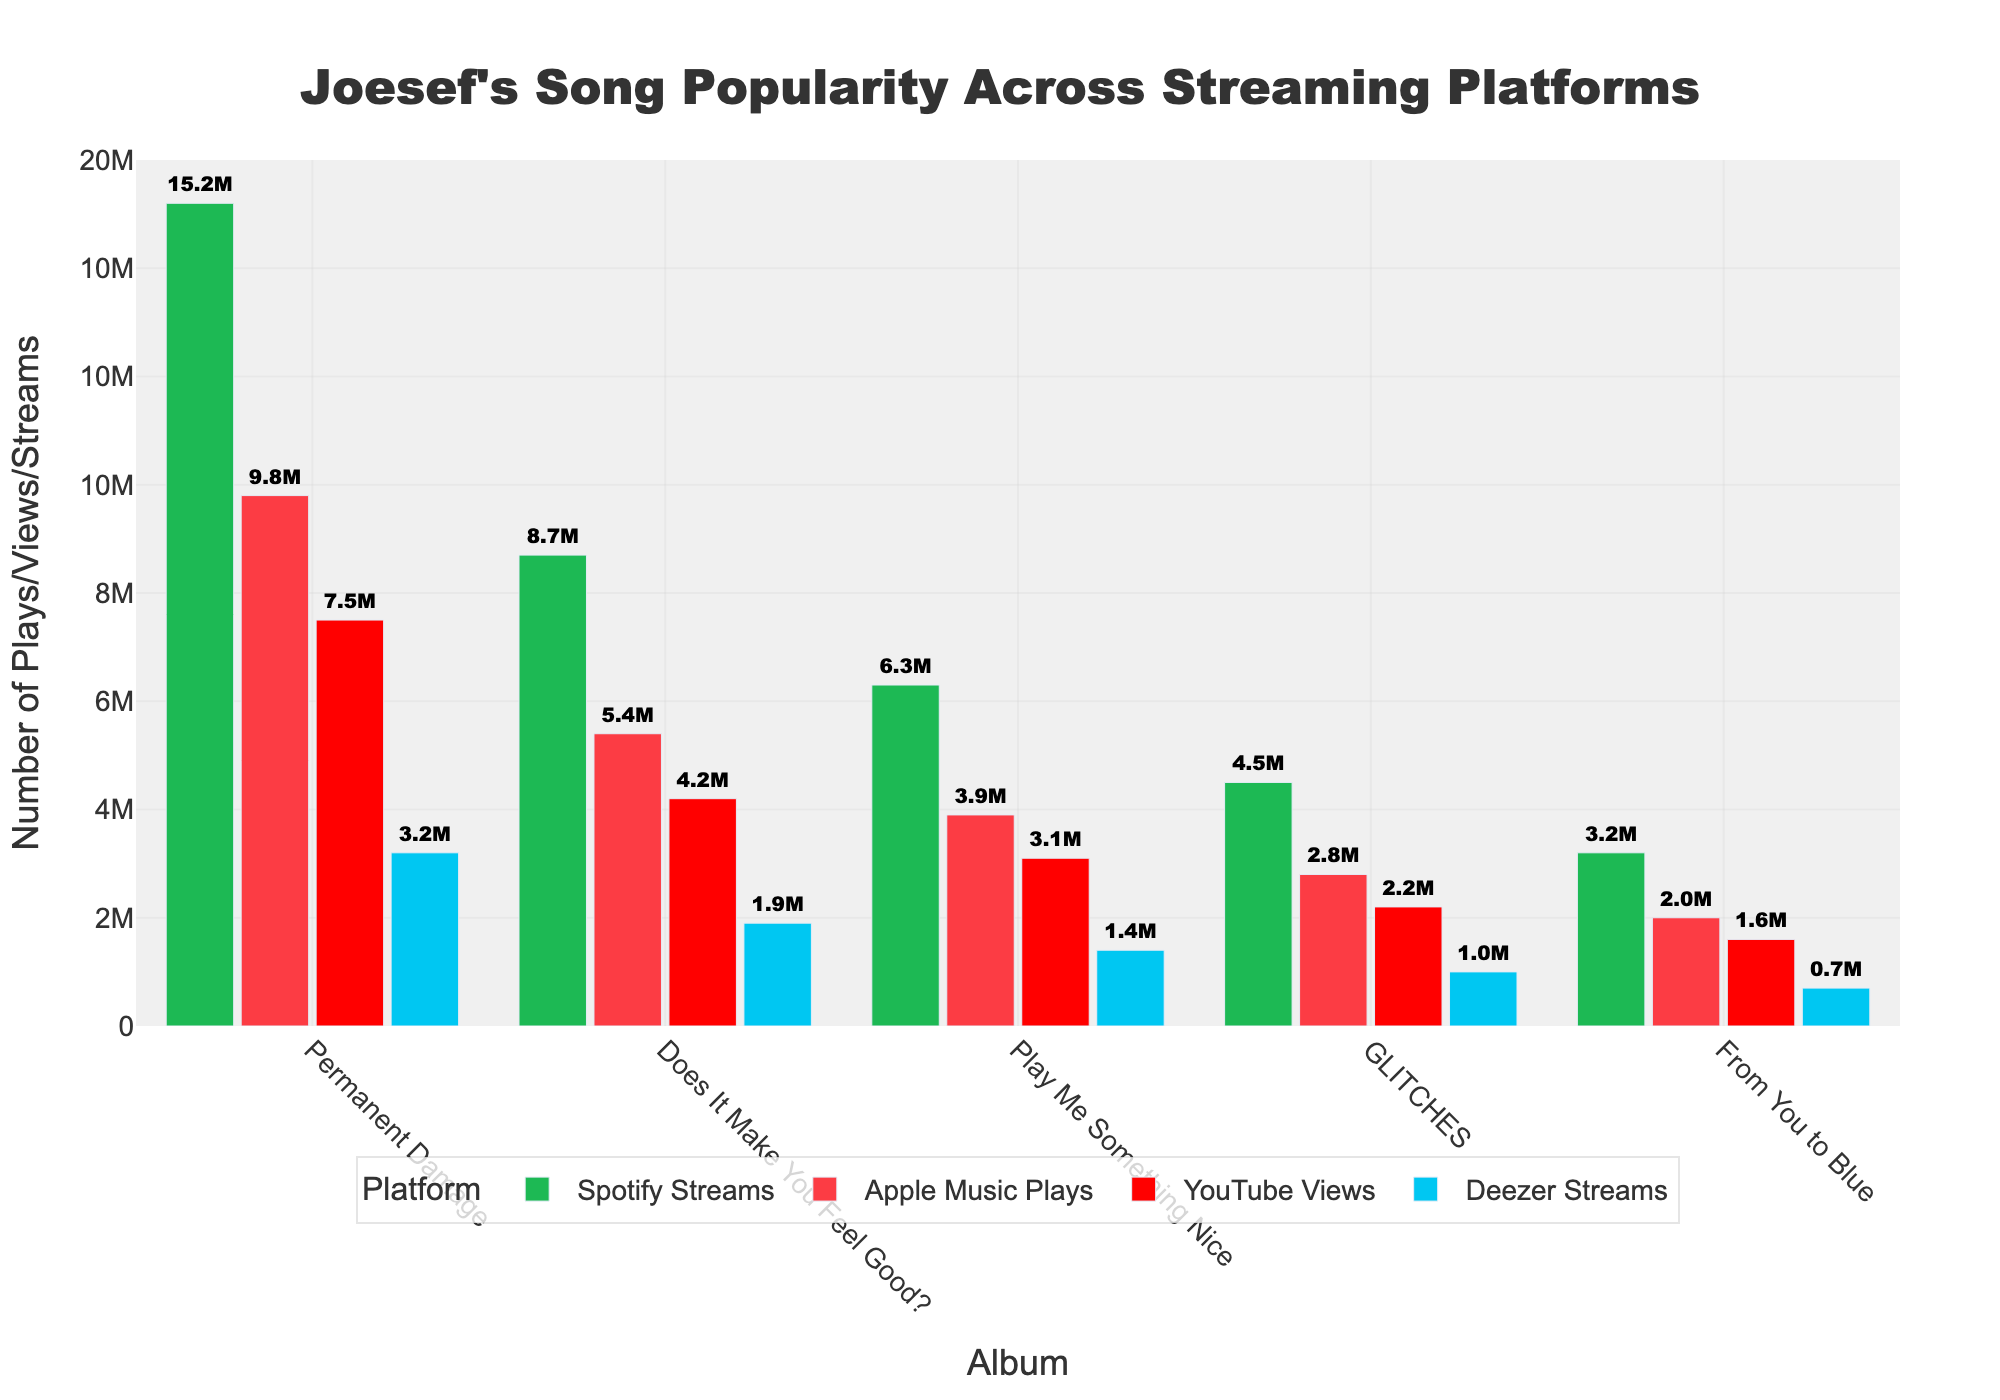Which album has the highest total streams across all platforms? To find the album with the highest total streams, sum the streams from all platforms for each album and compare. "Permanent Damage" has 15.2M on Spotify, 9.8M on Apple Music, 7.5M on YouTube, and 3.2M on Deezer. The combined total is 15.2 + 9.8 + 7.5 + 3.2 = 35.7M, which is the highest.
Answer: Permanent Damage Which platform has the least total streams for the "GLITCHES" album? To find the platform with the least streams, compare the values for the "GLITCHES" album across all platforms: Spotify (4.5M), Apple Music (2.8M), YouTube (2.2M), and Deezer (1M). The smallest value is 1M on Deezer.
Answer: Deezer What's the difference in YouTube views between "Does It Make You Feel Good?" and "From You to Blue"? To find the difference, subtract the YouTube views of "From You to Blue" from "Does It Make You Feel Good?": 4.2M - 1.6M = 2.6M.
Answer: 2.6M Which album has the most Apple Music plays and how many plays does it have? Check each album's Apple Music plays and find the highest value. "Permanent Damage" has the most with 9.8M plays.
Answer: Permanent Damage with 9.8M plays What is the combined number of Spotify Streams for "Play Me Something Nice" and "GLITCHES"? Add the Spotify Streams for "Play Me Something Nice" (6.3M) and "GLITCHES" (4.5M): 6.3 + 4.5 = 10.8M.
Answer: 10.8M Which bar is the tallest in the figure and what platform/album does it represent? Visually identify the tallest bar, which represents the platform/album with the highest single stream count. The tallest bar is green, representing 15.2M Spotify Streams for "Permanent Damage".
Answer: 15.2M Spotify Streams for Permanent Damage How many plays on Deezer does "Does It Make You Feel Good?" have compared to "From You to Blue"? Compare Deezer streams for both albums: "Does It Make You Feel Good?" has 1.9M, while "From You to Blue" has 0.7M. The difference is 1.9M - 0.7M = 1.2M.
Answer: 1.2M more What's the average number of plays on Apple Music across all albums? To find the average, sum the Apple Music plays for all albums and divide by the number of albums: (9.8M + 5.4M + 3.9M + 2.8M + 2.0M) / 5 = (23.9M) / 5 = 4.78M.
Answer: 4.78M Which album has the least total streams across all platforms? Sum the total streams for each album and identify the smallest value. "From You to Blue" has the least with a total of 3.2M + 2.0M + 1.6M + 0.7M = 7.5M.
Answer: From You to Blue How much more popular are the songs from "Permanent Damage" on Spotify than on Deezer? Subtract Deezer streams from Spotify Streams for "Permanent Damage": 15.2M - 3.2M = 12M.
Answer: 12M 